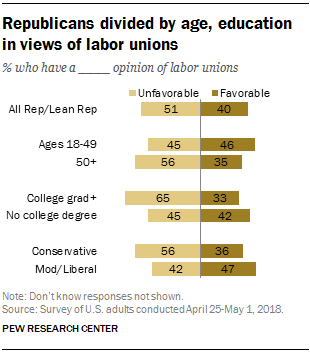Indicate a few pertinent items in this graphic. The sum of the two smallest unfavorable bars is greater than 60. What is the value of the top leftmost bar in the histogram? It is 51. 